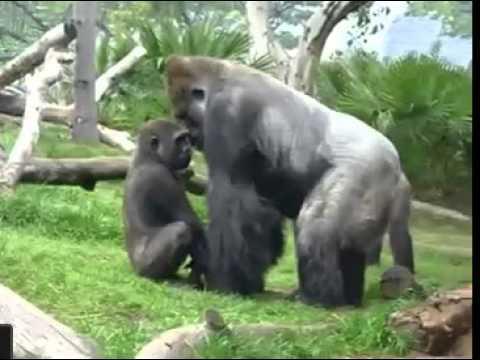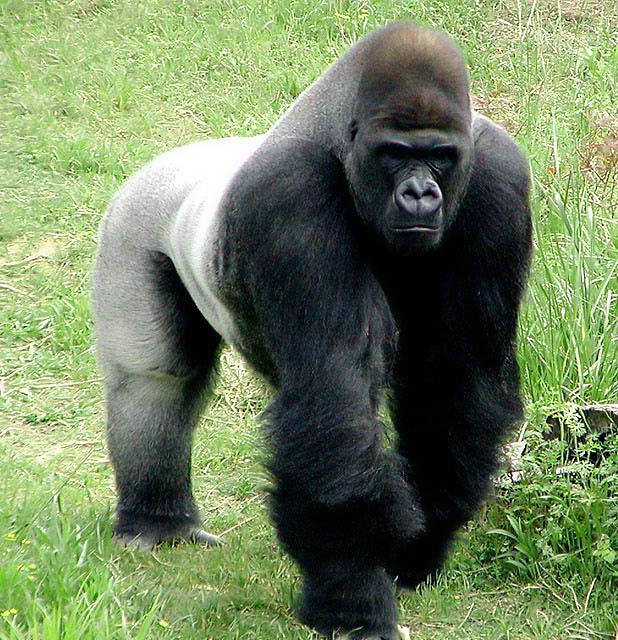The first image is the image on the left, the second image is the image on the right. Given the left and right images, does the statement "There is a single ape in the right image." hold true? Answer yes or no. Yes. The first image is the image on the left, the second image is the image on the right. Given the left and right images, does the statement "The gorilla in the left image is very close to another gorilla." hold true? Answer yes or no. Yes. 